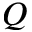Convert formula to latex. <formula><loc_0><loc_0><loc_500><loc_500>Q</formula> 